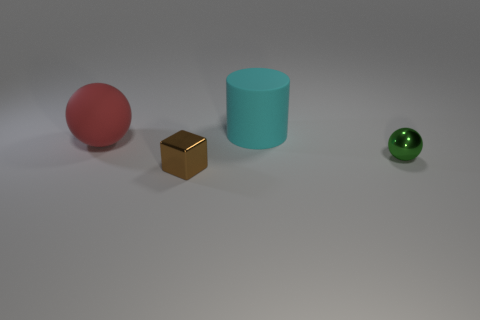The ball that is made of the same material as the small block is what size?
Your answer should be compact. Small. Are there fewer green metallic cubes than green things?
Ensure brevity in your answer.  Yes. How many large objects are cyan rubber objects or purple matte things?
Ensure brevity in your answer.  1. How many tiny things are on the right side of the small metal block and left of the large cylinder?
Your answer should be compact. 0. Are there more large cylinders than purple cylinders?
Provide a short and direct response. Yes. What number of other things are there of the same shape as the large cyan matte object?
Offer a very short reply. 0. Is the color of the big cylinder the same as the metal block?
Make the answer very short. No. The thing that is in front of the red matte thing and on the left side of the small green object is made of what material?
Provide a succinct answer. Metal. How big is the green thing?
Offer a terse response. Small. What number of large cyan cylinders are behind the sphere that is to the left of the tiny thing that is to the right of the big cylinder?
Give a very brief answer. 1. 